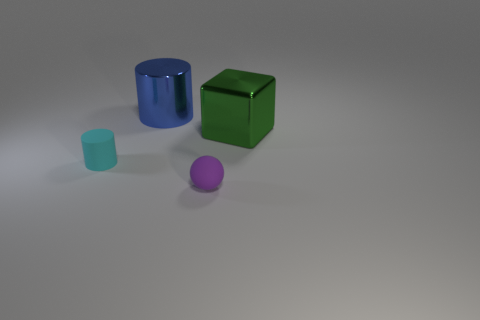Add 3 green matte spheres. How many objects exist? 7 Subtract all blocks. How many objects are left? 3 Add 3 purple rubber objects. How many purple rubber objects are left? 4 Add 2 large blue things. How many large blue things exist? 3 Subtract 0 yellow spheres. How many objects are left? 4 Subtract all green things. Subtract all metal cylinders. How many objects are left? 2 